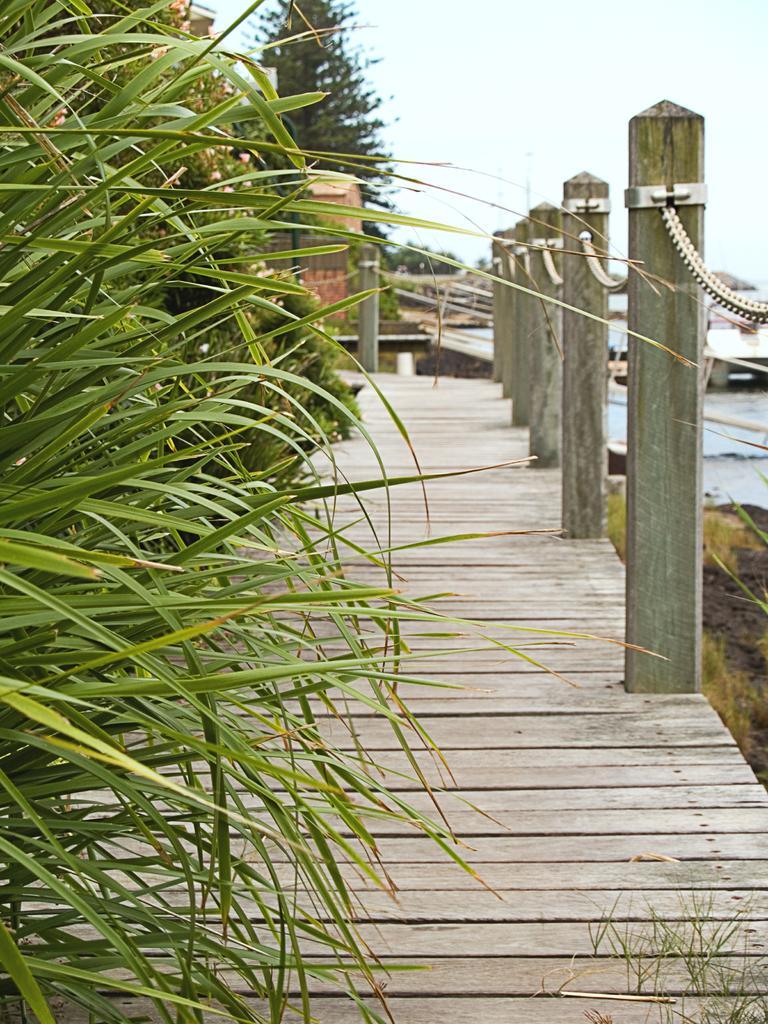How would you summarize this image in a sentence or two? On the left side we can see plants at the bridge and we can see poles and chain like a fence. In the background there is a tree, grass on the ground, boat on the water and sky. 